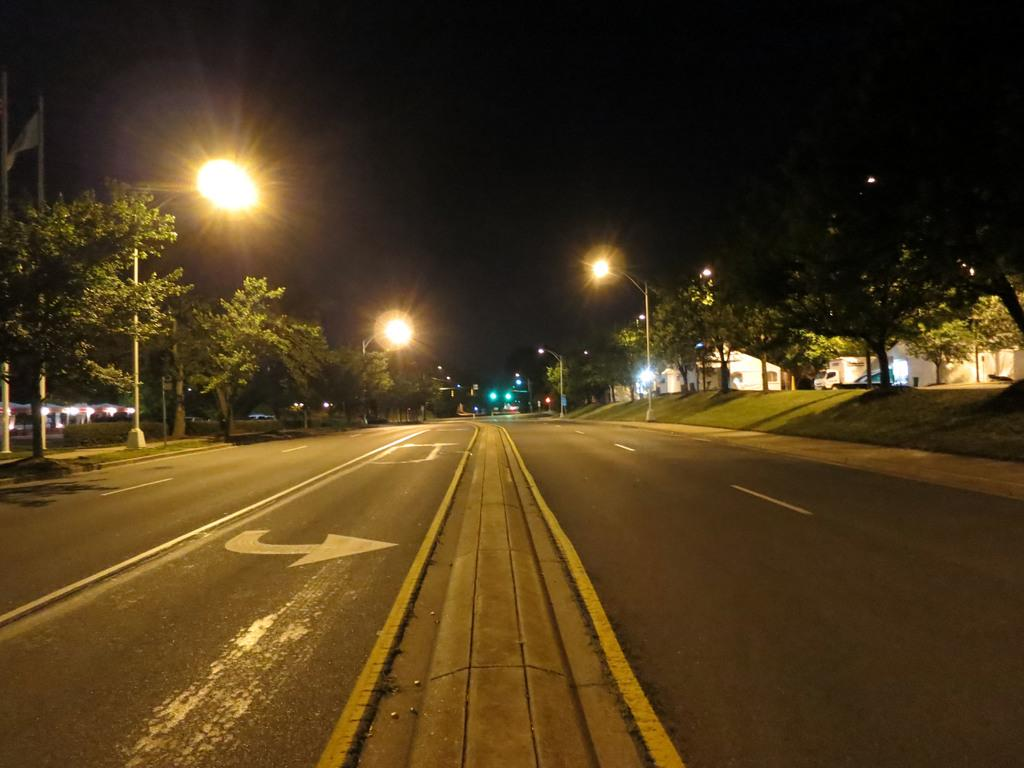What type of structures can be seen in the image? There are buildings in the image. What other natural elements are present in the image? There are trees in the image. What type of lighting is present in the image? There are street lights in the image. What is visible at the top of the image? The sky is visible at the top of the image. What type of surface is at the bottom of the image? There is a road at the bottom of the image. What mode of transportation can be seen on the left side of the image? There is a vehicle on the left side of the image. Where is the cabbage growing in the image? There is no cabbage present in the image. What type of oven is visible in the image? There is no oven present in the image. 